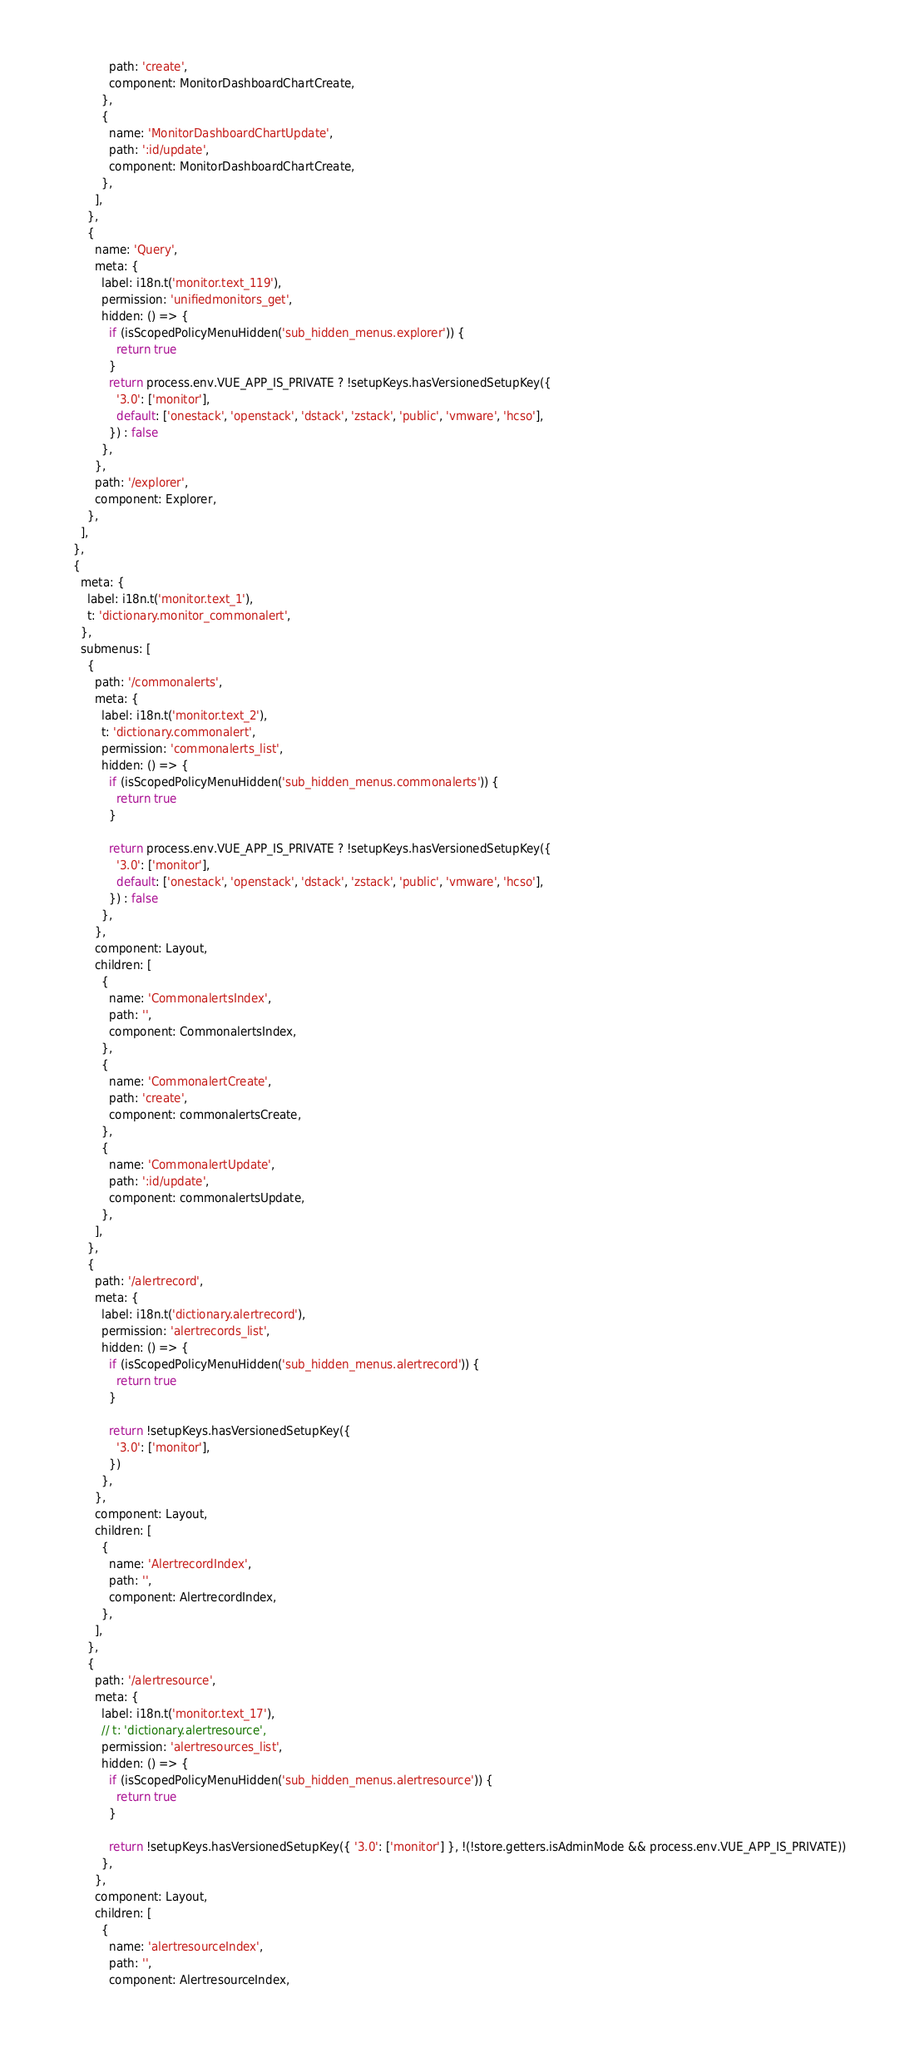Convert code to text. <code><loc_0><loc_0><loc_500><loc_500><_JavaScript_>              path: 'create',
              component: MonitorDashboardChartCreate,
            },
            {
              name: 'MonitorDashboardChartUpdate',
              path: ':id/update',
              component: MonitorDashboardChartCreate,
            },
          ],
        },
        {
          name: 'Query',
          meta: {
            label: i18n.t('monitor.text_119'),
            permission: 'unifiedmonitors_get',
            hidden: () => {
              if (isScopedPolicyMenuHidden('sub_hidden_menus.explorer')) {
                return true
              }
              return process.env.VUE_APP_IS_PRIVATE ? !setupKeys.hasVersionedSetupKey({
                '3.0': ['monitor'],
                default: ['onestack', 'openstack', 'dstack', 'zstack', 'public', 'vmware', 'hcso'],
              }) : false
            },
          },
          path: '/explorer',
          component: Explorer,
        },
      ],
    },
    {
      meta: {
        label: i18n.t('monitor.text_1'),
        t: 'dictionary.monitor_commonalert',
      },
      submenus: [
        {
          path: '/commonalerts',
          meta: {
            label: i18n.t('monitor.text_2'),
            t: 'dictionary.commonalert',
            permission: 'commonalerts_list',
            hidden: () => {
              if (isScopedPolicyMenuHidden('sub_hidden_menus.commonalerts')) {
                return true
              }

              return process.env.VUE_APP_IS_PRIVATE ? !setupKeys.hasVersionedSetupKey({
                '3.0': ['monitor'],
                default: ['onestack', 'openstack', 'dstack', 'zstack', 'public', 'vmware', 'hcso'],
              }) : false
            },
          },
          component: Layout,
          children: [
            {
              name: 'CommonalertsIndex',
              path: '',
              component: CommonalertsIndex,
            },
            {
              name: 'CommonalertCreate',
              path: 'create',
              component: commonalertsCreate,
            },
            {
              name: 'CommonalertUpdate',
              path: ':id/update',
              component: commonalertsUpdate,
            },
          ],
        },
        {
          path: '/alertrecord',
          meta: {
            label: i18n.t('dictionary.alertrecord'),
            permission: 'alertrecords_list',
            hidden: () => {
              if (isScopedPolicyMenuHidden('sub_hidden_menus.alertrecord')) {
                return true
              }

              return !setupKeys.hasVersionedSetupKey({
                '3.0': ['monitor'],
              })
            },
          },
          component: Layout,
          children: [
            {
              name: 'AlertrecordIndex',
              path: '',
              component: AlertrecordIndex,
            },
          ],
        },
        {
          path: '/alertresource',
          meta: {
            label: i18n.t('monitor.text_17'),
            // t: 'dictionary.alertresource',
            permission: 'alertresources_list',
            hidden: () => {
              if (isScopedPolicyMenuHidden('sub_hidden_menus.alertresource')) {
                return true
              }

              return !setupKeys.hasVersionedSetupKey({ '3.0': ['monitor'] }, !(!store.getters.isAdminMode && process.env.VUE_APP_IS_PRIVATE))
            },
          },
          component: Layout,
          children: [
            {
              name: 'alertresourceIndex',
              path: '',
              component: AlertresourceIndex,</code> 